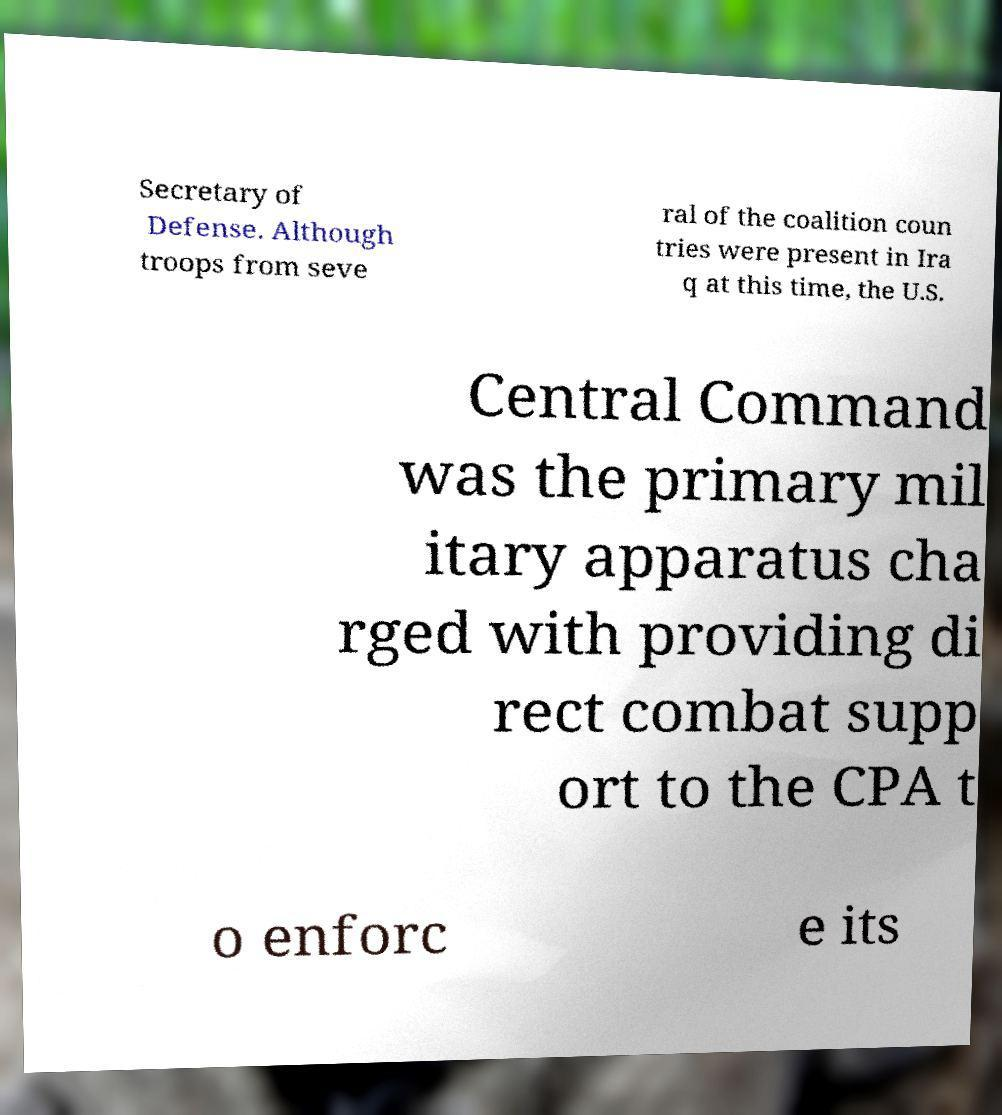Can you accurately transcribe the text from the provided image for me? Secretary of Defense. Although troops from seve ral of the coalition coun tries were present in Ira q at this time, the U.S. Central Command was the primary mil itary apparatus cha rged with providing di rect combat supp ort to the CPA t o enforc e its 